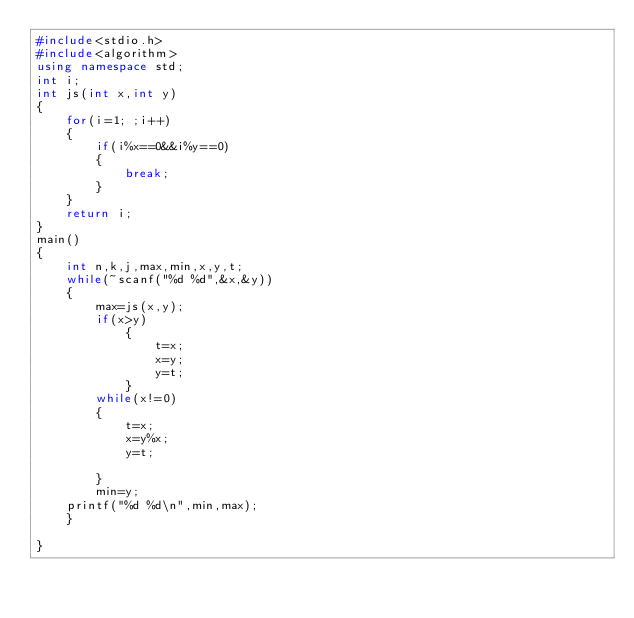Convert code to text. <code><loc_0><loc_0><loc_500><loc_500><_C++_>#include<stdio.h>
#include<algorithm>
using namespace std;
int i;
int js(int x,int y)
{
    for(i=1; ;i++)
    {
        if(i%x==0&&i%y==0)
        {
            break;
        }
    }
    return i;
}
main()
{
    int n,k,j,max,min,x,y,t;
    while(~scanf("%d %d",&x,&y))
    {
        max=js(x,y);
        if(x>y)
            {
                t=x;
                x=y;
                y=t;
            }
        while(x!=0)
        {
            t=x;
            x=y%x;
            y=t;

        }
        min=y;
    printf("%d %d\n",min,max);
    }

}</code> 